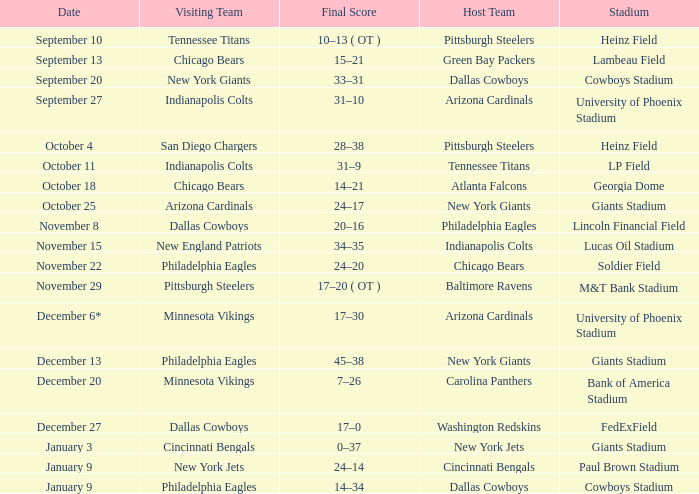Give me the full table as a dictionary. {'header': ['Date', 'Visiting Team', 'Final Score', 'Host Team', 'Stadium'], 'rows': [['September 10', 'Tennessee Titans', '10–13 ( OT )', 'Pittsburgh Steelers', 'Heinz Field'], ['September 13', 'Chicago Bears', '15–21', 'Green Bay Packers', 'Lambeau Field'], ['September 20', 'New York Giants', '33–31', 'Dallas Cowboys', 'Cowboys Stadium'], ['September 27', 'Indianapolis Colts', '31–10', 'Arizona Cardinals', 'University of Phoenix Stadium'], ['October 4', 'San Diego Chargers', '28–38', 'Pittsburgh Steelers', 'Heinz Field'], ['October 11', 'Indianapolis Colts', '31–9', 'Tennessee Titans', 'LP Field'], ['October 18', 'Chicago Bears', '14–21', 'Atlanta Falcons', 'Georgia Dome'], ['October 25', 'Arizona Cardinals', '24–17', 'New York Giants', 'Giants Stadium'], ['November 8', 'Dallas Cowboys', '20–16', 'Philadelphia Eagles', 'Lincoln Financial Field'], ['November 15', 'New England Patriots', '34–35', 'Indianapolis Colts', 'Lucas Oil Stadium'], ['November 22', 'Philadelphia Eagles', '24–20', 'Chicago Bears', 'Soldier Field'], ['November 29', 'Pittsburgh Steelers', '17–20 ( OT )', 'Baltimore Ravens', 'M&T Bank Stadium'], ['December 6*', 'Minnesota Vikings', '17–30', 'Arizona Cardinals', 'University of Phoenix Stadium'], ['December 13', 'Philadelphia Eagles', '45–38', 'New York Giants', 'Giants Stadium'], ['December 20', 'Minnesota Vikings', '7–26', 'Carolina Panthers', 'Bank of America Stadium'], ['December 27', 'Dallas Cowboys', '17–0', 'Washington Redskins', 'FedExField'], ['January 3', 'Cincinnati Bengals', '0–37', 'New York Jets', 'Giants Stadium'], ['January 9', 'New York Jets', '24–14', 'Cincinnati Bengals', 'Paul Brown Stadium'], ['January 9', 'Philadelphia Eagles', '14–34', 'Dallas Cowboys', 'Cowboys Stadium']]} Can you provide the date of the pittsburgh steelers game? November 29. 